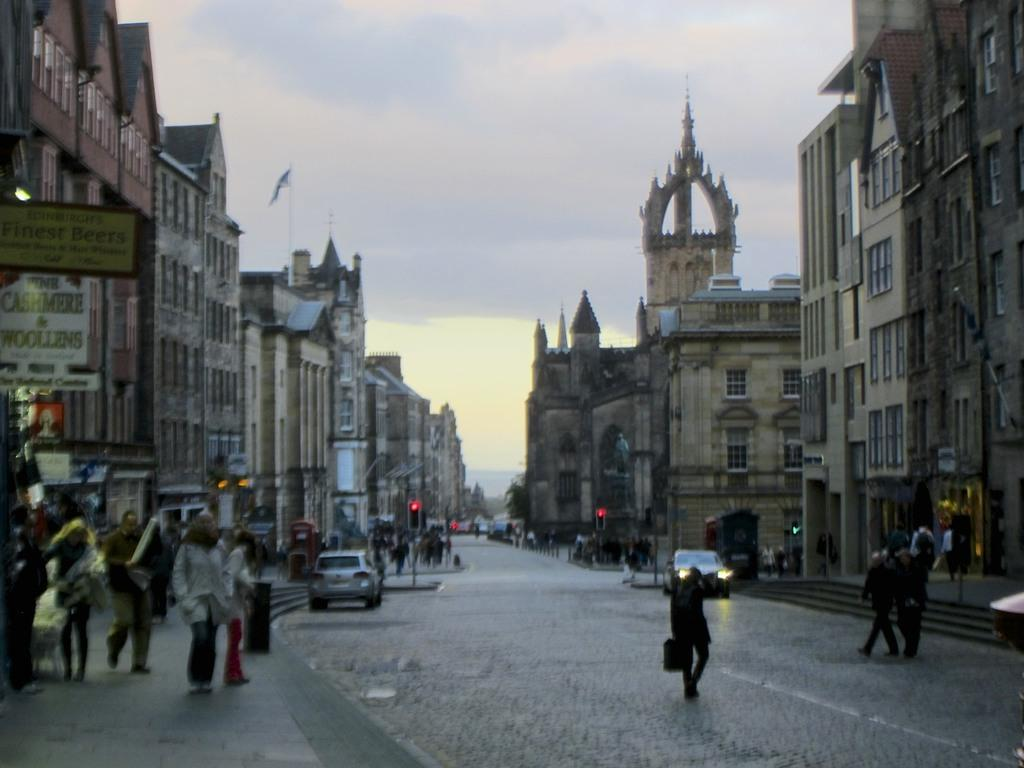How many people are in the image? There are people in the image, but the exact number is not specified. What types of vehicles can be seen in the image? There are vehicles in the image, but the specific types are not mentioned. What is the primary feature of the road in the image? The road is a feature in the image, but its specific characteristics are not described. Where are the stairs located in the image? The stairs are in the image, but their exact location is not specified. What are the walkways used for in the image? The walkways are in the image, but their purpose is not described. How many buildings are visible in the image? There are buildings in the image, but the exact number is not specified. What information do the name boards provide in the image? The name boards are in the image, but their specific content is not described. What colors are visible on the traffic signals in the image? The traffic signals are in the image, but their specific colors are not mentioned. Are there any people walking in the image? Yes, some people are walking in the image. What can be seen in the background of the image? The sky is visible in the background of the image. Where is the coil located in the image? There is no coil present in the image. What type of hydrant can be seen near the walkways in the image? There is no hydrant present in the image. 